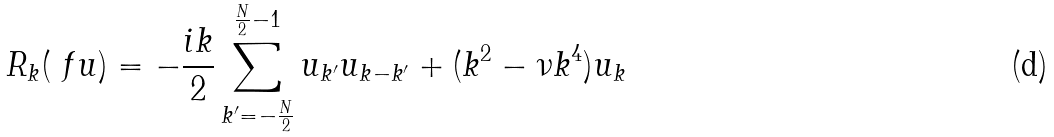<formula> <loc_0><loc_0><loc_500><loc_500>R _ { k } ( { \ f u } ) = - \frac { i k } { 2 } \sum _ { k ^ { \prime } = - \frac { N } { 2 } } ^ { \frac { N } { 2 } - 1 } u _ { k ^ { \prime } } u _ { k - k ^ { \prime } } + ( k ^ { 2 } - \nu k ^ { 4 } ) u _ { k }</formula> 